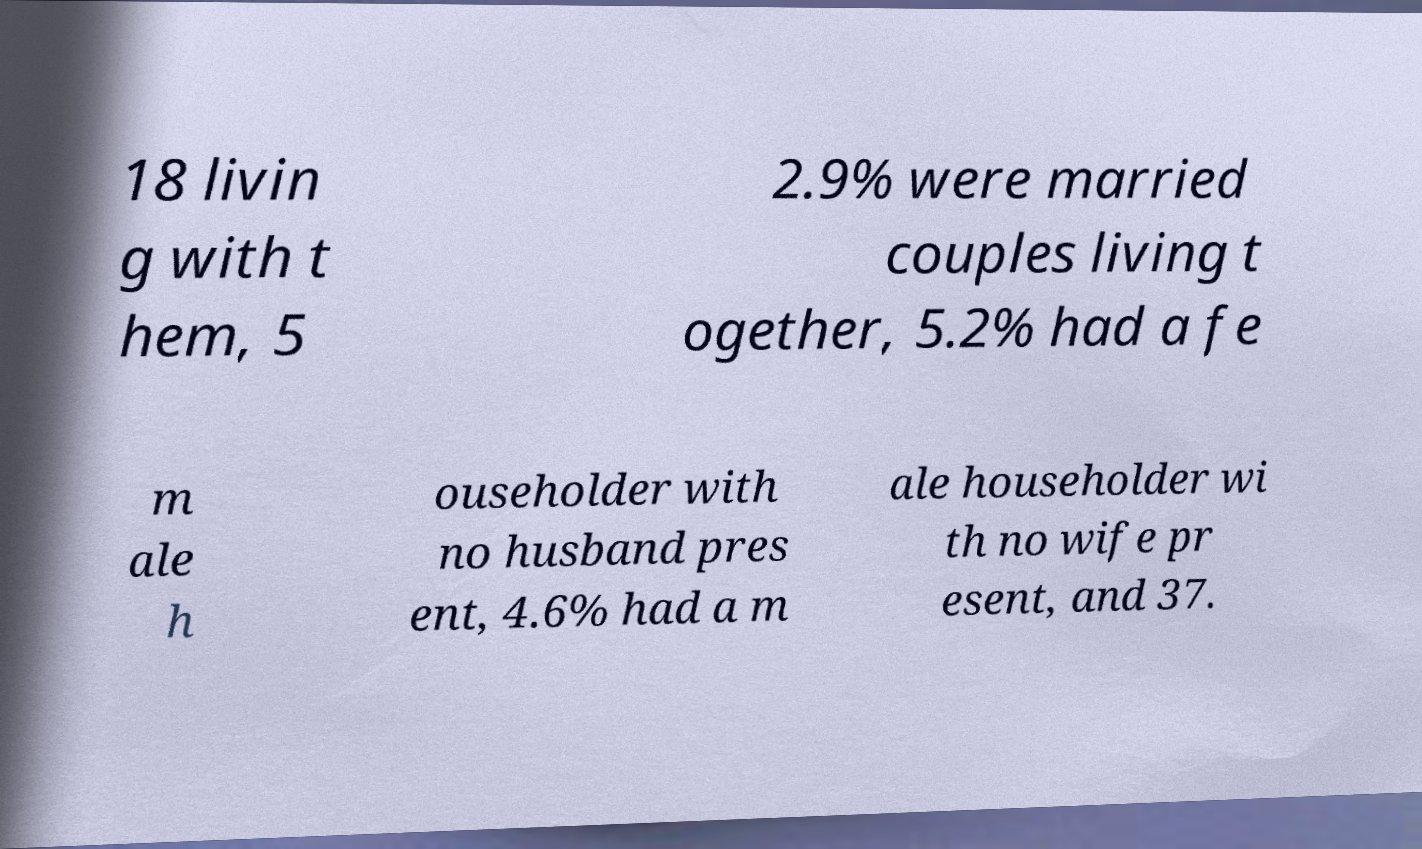Can you read and provide the text displayed in the image?This photo seems to have some interesting text. Can you extract and type it out for me? 18 livin g with t hem, 5 2.9% were married couples living t ogether, 5.2% had a fe m ale h ouseholder with no husband pres ent, 4.6% had a m ale householder wi th no wife pr esent, and 37. 